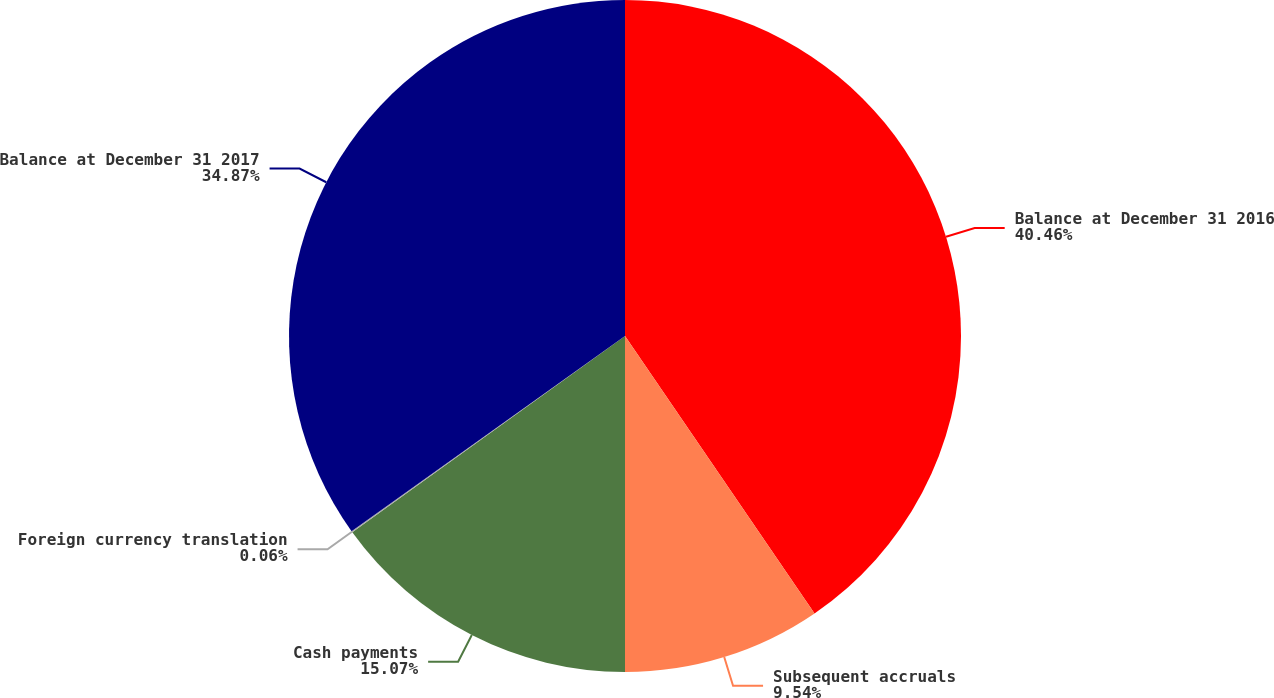Convert chart. <chart><loc_0><loc_0><loc_500><loc_500><pie_chart><fcel>Balance at December 31 2016<fcel>Subsequent accruals<fcel>Cash payments<fcel>Foreign currency translation<fcel>Balance at December 31 2017<nl><fcel>40.46%<fcel>9.54%<fcel>15.07%<fcel>0.06%<fcel>34.87%<nl></chart> 